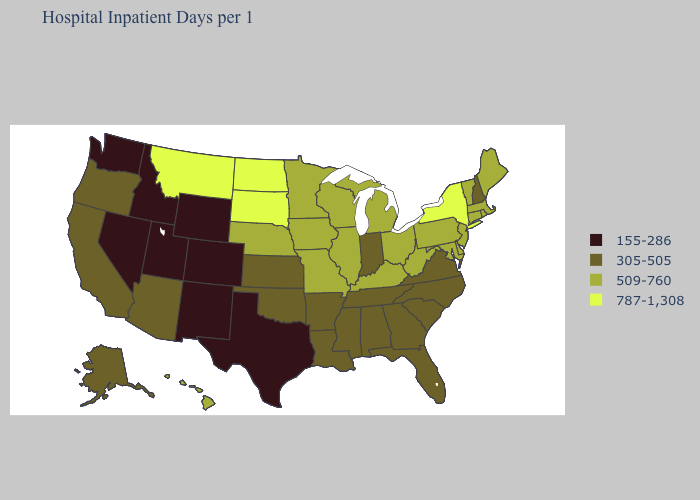Name the states that have a value in the range 509-760?
Keep it brief. Connecticut, Delaware, Hawaii, Illinois, Iowa, Kentucky, Maine, Maryland, Massachusetts, Michigan, Minnesota, Missouri, Nebraska, New Jersey, Ohio, Pennsylvania, Rhode Island, Vermont, West Virginia, Wisconsin. What is the highest value in states that border Arizona?
Write a very short answer. 305-505. Name the states that have a value in the range 155-286?
Be succinct. Colorado, Idaho, Nevada, New Mexico, Texas, Utah, Washington, Wyoming. Does New York have the highest value in the USA?
Concise answer only. Yes. Name the states that have a value in the range 305-505?
Quick response, please. Alabama, Alaska, Arizona, Arkansas, California, Florida, Georgia, Indiana, Kansas, Louisiana, Mississippi, New Hampshire, North Carolina, Oklahoma, Oregon, South Carolina, Tennessee, Virginia. Name the states that have a value in the range 305-505?
Answer briefly. Alabama, Alaska, Arizona, Arkansas, California, Florida, Georgia, Indiana, Kansas, Louisiana, Mississippi, New Hampshire, North Carolina, Oklahoma, Oregon, South Carolina, Tennessee, Virginia. Which states have the lowest value in the South?
Write a very short answer. Texas. What is the highest value in the USA?
Give a very brief answer. 787-1,308. Is the legend a continuous bar?
Write a very short answer. No. What is the value of Kansas?
Write a very short answer. 305-505. Does the map have missing data?
Keep it brief. No. What is the value of Vermont?
Quick response, please. 509-760. Does the first symbol in the legend represent the smallest category?
Write a very short answer. Yes. Is the legend a continuous bar?
Concise answer only. No. What is the highest value in the USA?
Write a very short answer. 787-1,308. 